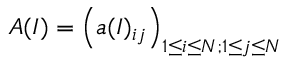<formula> <loc_0><loc_0><loc_500><loc_500>A ( I ) = \left ( a ( I ) _ { i j } \right ) _ { 1 \leq i \leq N ; 1 \leq j \leq N }</formula> 